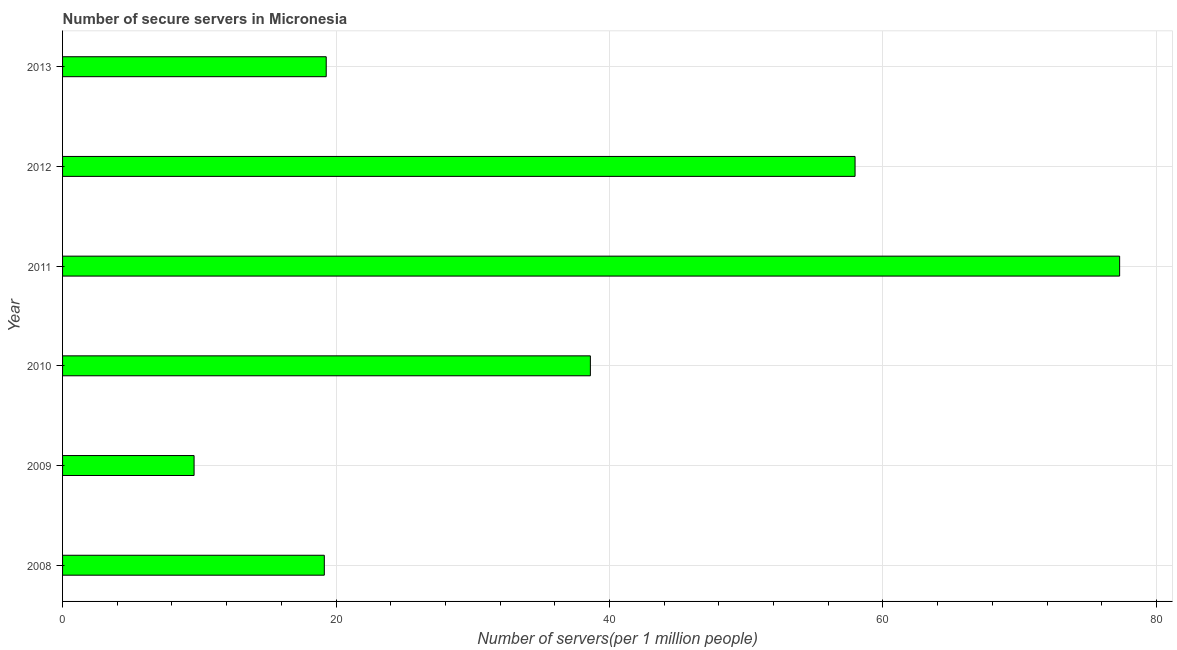Does the graph contain any zero values?
Keep it short and to the point. No. What is the title of the graph?
Provide a succinct answer. Number of secure servers in Micronesia. What is the label or title of the X-axis?
Provide a succinct answer. Number of servers(per 1 million people). What is the number of secure internet servers in 2008?
Make the answer very short. 19.14. Across all years, what is the maximum number of secure internet servers?
Offer a very short reply. 77.31. Across all years, what is the minimum number of secure internet servers?
Your answer should be compact. 9.62. In which year was the number of secure internet servers maximum?
Offer a very short reply. 2011. What is the sum of the number of secure internet servers?
Make the answer very short. 221.92. What is the difference between the number of secure internet servers in 2008 and 2009?
Your answer should be very brief. 9.53. What is the average number of secure internet servers per year?
Your response must be concise. 36.99. What is the median number of secure internet servers?
Provide a succinct answer. 28.94. In how many years, is the number of secure internet servers greater than 60 ?
Offer a very short reply. 1. What is the ratio of the number of secure internet servers in 2009 to that in 2011?
Provide a short and direct response. 0.12. Is the number of secure internet servers in 2009 less than that in 2011?
Ensure brevity in your answer.  Yes. Is the difference between the number of secure internet servers in 2011 and 2012 greater than the difference between any two years?
Give a very brief answer. No. What is the difference between the highest and the second highest number of secure internet servers?
Offer a very short reply. 19.35. Is the sum of the number of secure internet servers in 2009 and 2011 greater than the maximum number of secure internet servers across all years?
Your answer should be compact. Yes. What is the difference between the highest and the lowest number of secure internet servers?
Offer a terse response. 67.69. How many years are there in the graph?
Ensure brevity in your answer.  6. What is the Number of servers(per 1 million people) of 2008?
Ensure brevity in your answer.  19.14. What is the Number of servers(per 1 million people) of 2009?
Keep it short and to the point. 9.62. What is the Number of servers(per 1 million people) in 2010?
Give a very brief answer. 38.6. What is the Number of servers(per 1 million people) of 2011?
Keep it short and to the point. 77.31. What is the Number of servers(per 1 million people) of 2012?
Offer a terse response. 57.96. What is the Number of servers(per 1 million people) in 2013?
Offer a terse response. 19.28. What is the difference between the Number of servers(per 1 million people) in 2008 and 2009?
Give a very brief answer. 9.52. What is the difference between the Number of servers(per 1 million people) in 2008 and 2010?
Your response must be concise. -19.46. What is the difference between the Number of servers(per 1 million people) in 2008 and 2011?
Make the answer very short. -58.17. What is the difference between the Number of servers(per 1 million people) in 2008 and 2012?
Your answer should be compact. -38.82. What is the difference between the Number of servers(per 1 million people) in 2008 and 2013?
Your response must be concise. -0.14. What is the difference between the Number of servers(per 1 million people) in 2009 and 2010?
Provide a succinct answer. -28.98. What is the difference between the Number of servers(per 1 million people) in 2009 and 2011?
Your response must be concise. -67.69. What is the difference between the Number of servers(per 1 million people) in 2009 and 2012?
Make the answer very short. -48.34. What is the difference between the Number of servers(per 1 million people) in 2009 and 2013?
Your answer should be very brief. -9.66. What is the difference between the Number of servers(per 1 million people) in 2010 and 2011?
Ensure brevity in your answer.  -38.71. What is the difference between the Number of servers(per 1 million people) in 2010 and 2012?
Provide a succinct answer. -19.36. What is the difference between the Number of servers(per 1 million people) in 2010 and 2013?
Your answer should be very brief. 19.32. What is the difference between the Number of servers(per 1 million people) in 2011 and 2012?
Your answer should be compact. 19.35. What is the difference between the Number of servers(per 1 million people) in 2011 and 2013?
Your response must be concise. 58.03. What is the difference between the Number of servers(per 1 million people) in 2012 and 2013?
Provide a succinct answer. 38.68. What is the ratio of the Number of servers(per 1 million people) in 2008 to that in 2009?
Provide a succinct answer. 1.99. What is the ratio of the Number of servers(per 1 million people) in 2008 to that in 2010?
Provide a succinct answer. 0.5. What is the ratio of the Number of servers(per 1 million people) in 2008 to that in 2011?
Your response must be concise. 0.25. What is the ratio of the Number of servers(per 1 million people) in 2008 to that in 2012?
Your response must be concise. 0.33. What is the ratio of the Number of servers(per 1 million people) in 2009 to that in 2010?
Give a very brief answer. 0.25. What is the ratio of the Number of servers(per 1 million people) in 2009 to that in 2011?
Keep it short and to the point. 0.12. What is the ratio of the Number of servers(per 1 million people) in 2009 to that in 2012?
Provide a succinct answer. 0.17. What is the ratio of the Number of servers(per 1 million people) in 2009 to that in 2013?
Provide a short and direct response. 0.5. What is the ratio of the Number of servers(per 1 million people) in 2010 to that in 2011?
Keep it short and to the point. 0.5. What is the ratio of the Number of servers(per 1 million people) in 2010 to that in 2012?
Offer a very short reply. 0.67. What is the ratio of the Number of servers(per 1 million people) in 2010 to that in 2013?
Give a very brief answer. 2. What is the ratio of the Number of servers(per 1 million people) in 2011 to that in 2012?
Keep it short and to the point. 1.33. What is the ratio of the Number of servers(per 1 million people) in 2011 to that in 2013?
Offer a very short reply. 4.01. What is the ratio of the Number of servers(per 1 million people) in 2012 to that in 2013?
Your answer should be very brief. 3.01. 